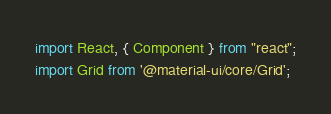<code> <loc_0><loc_0><loc_500><loc_500><_JavaScript_>import React, { Component } from "react";
import Grid from '@material-ui/core/Grid';</code> 